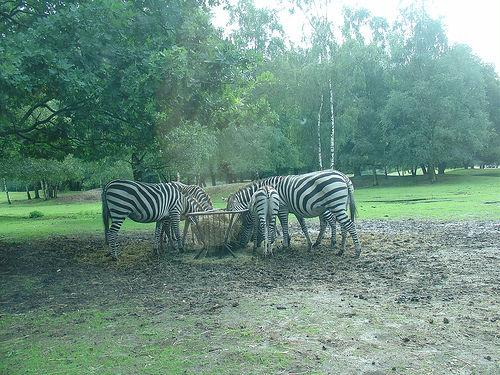These animals are mascots for what brand of gum?

Choices:
A) doublemint
B) trident
C) dubble bubble
D) fruit stripe fruit stripe 